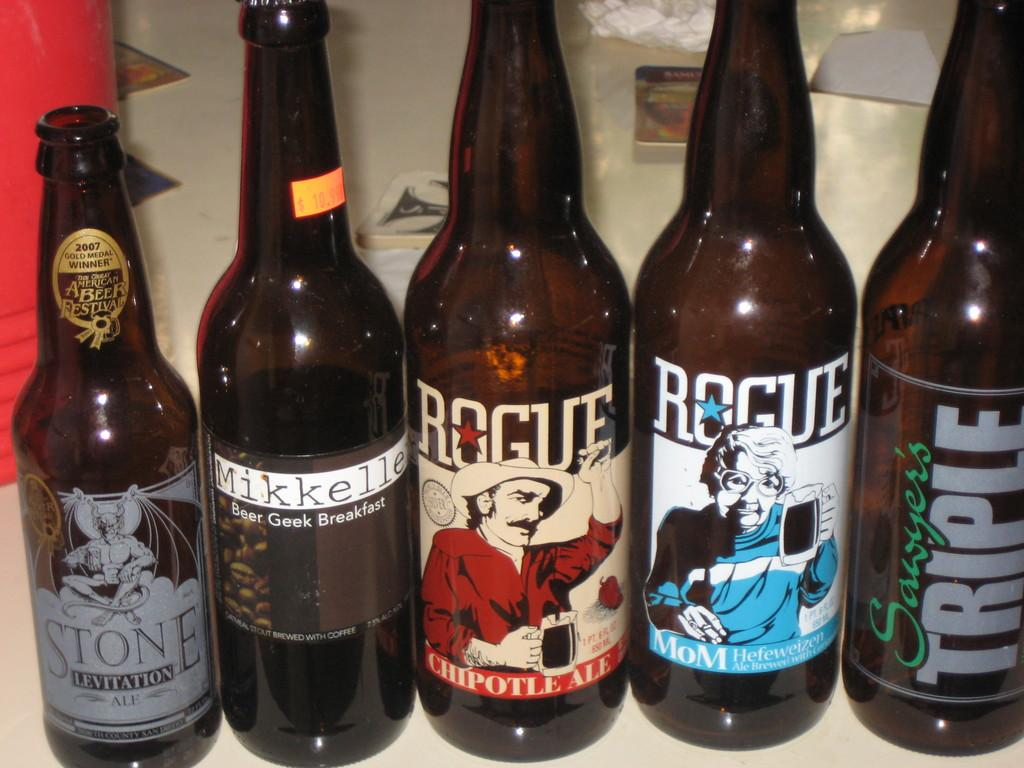How many wine bottles are visible in the image? There are five wine bottles in the image. What is the weather like in the image? There is no information about the weather in the image, as it only features five wine bottles. Can you describe the cough of the person in the image? There is no person present in the image, so it is not possible to describe their cough. 